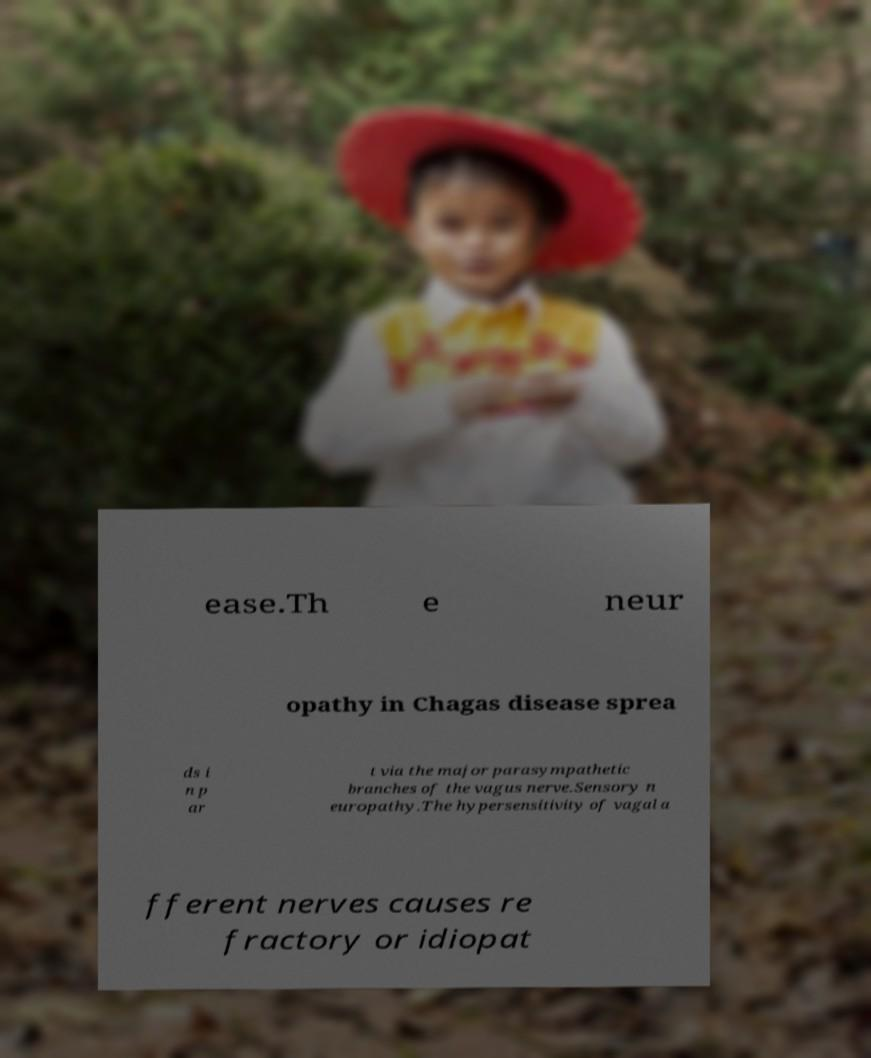Can you accurately transcribe the text from the provided image for me? ease.Th e neur opathy in Chagas disease sprea ds i n p ar t via the major parasympathetic branches of the vagus nerve.Sensory n europathy.The hypersensitivity of vagal a fferent nerves causes re fractory or idiopat 